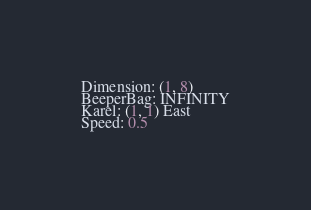Convert code to text. <code><loc_0><loc_0><loc_500><loc_500><_C_>Dimension: (1, 8)
BeeperBag: INFINITY
Karel: (1, 1) East
Speed: 0.5
</code> 